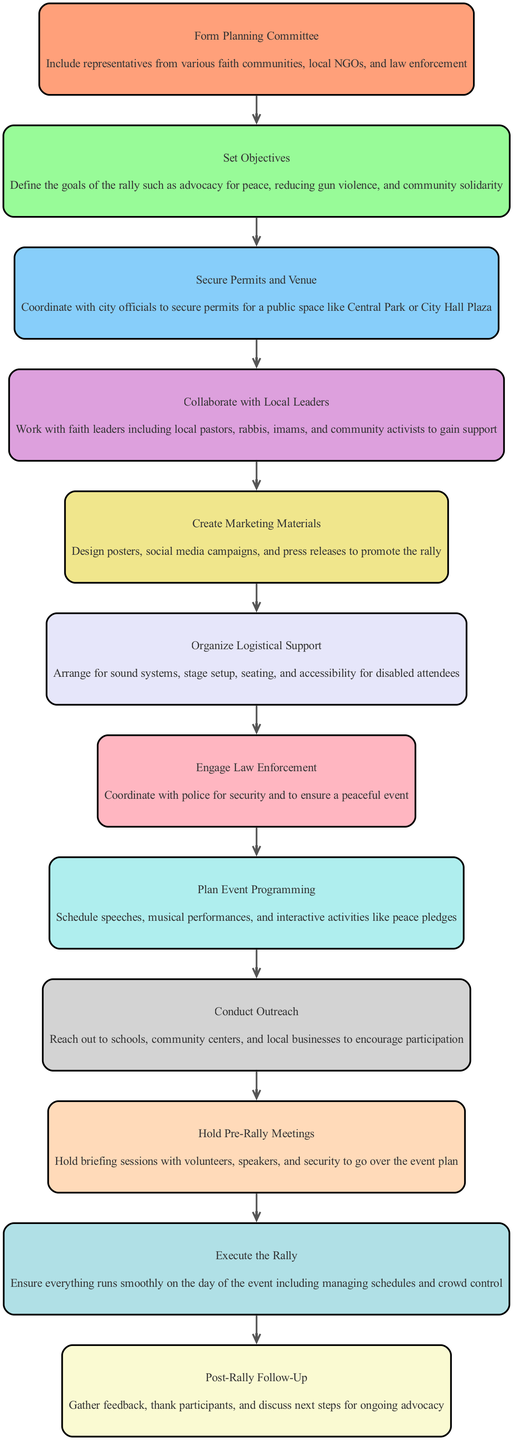What is the first step in organizing the rally? The first step listed in the diagram is "Form Planning Committee". This is indicated as the starting node in the flow chart, highlighting the initial action to take in the process.
Answer: Form Planning Committee How many steps are involved in the diagram? By counting the nodes in the flow chart, there are a total of 12 steps outlined for organizing the multi-faith peace rally.
Answer: 12 What is the purpose of the step "Set Objectives"? The details under "Set Objectives" include goals such as advocacy for peace, reducing gun violence, and community solidarity. This reflects the intention behind establishing clear objectives for the rally.
Answer: Define goals Which step directly follows "Secure Permits and Venue"? According to the flow chart, the step that follows "Secure Permits and Venue" is "Collaborate with Local Leaders". This indicates a sequence in the planning process where after securing the location, collaboration is sought.
Answer: Collaborate with Local Leaders What is the last step mentioned in the flow chart? The final step shown in the diagram is "Post-Rally Follow-Up". This represents the wrap-up phase after the event has taken place, focusing on feedback and future advocacy.
Answer: Post-Rally Follow-Up How many connections are there between steps in the diagram? There are 11 connections between steps, as each step is linked to the subsequent step, forming a continuous flow until the last step.
Answer: 11 What actions are included in the "Conduct Outreach" step? The "Conduct Outreach" step mentions reaching out to schools, community centers, and local businesses. This outlines specific target groups for encouraging participation in the rally.
Answer: Reach out to schools, community centers, and local businesses Which step emphasizes coordination with law enforcement? The step titled "Engage Law Enforcement" specifically highlights the need to coordinate with police for security to ensure a peaceful event, indicating importance in public safety measures during the rally.
Answer: Engage Law Enforcement What is required in "Organize Logistical Support"? The details under "Organize Logistical Support" specify arranging sound systems, stage setup, seating, and ensuring accessibility for disabled attendees, indicating the necessities for event facilitation.
Answer: Arrange sound systems and stage setup, seating, and accessibility 